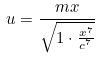Convert formula to latex. <formula><loc_0><loc_0><loc_500><loc_500>u = \frac { m x } { \sqrt { 1 \cdot \frac { x ^ { 7 } } { c ^ { 7 } } } }</formula> 